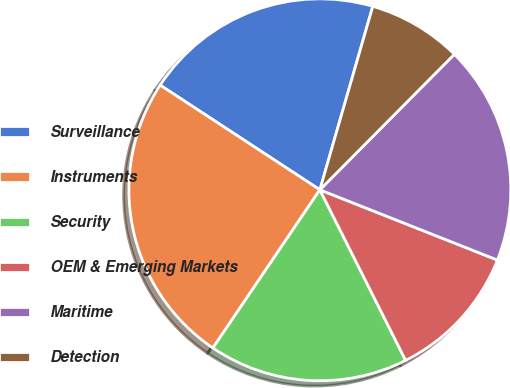Convert chart. <chart><loc_0><loc_0><loc_500><loc_500><pie_chart><fcel>Surveillance<fcel>Instruments<fcel>Security<fcel>OEM & Emerging Markets<fcel>Maritime<fcel>Detection<nl><fcel>20.24%<fcel>24.77%<fcel>16.88%<fcel>11.59%<fcel>18.56%<fcel>7.97%<nl></chart> 